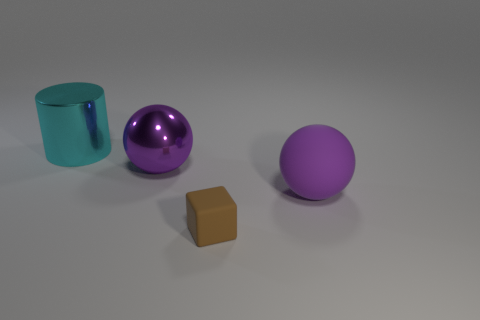Are there an equal number of tiny brown objects right of the small brown block and cylinders on the right side of the big purple rubber ball?
Provide a succinct answer. Yes. How many other things are there of the same color as the big rubber object?
Offer a terse response. 1. Does the metallic cylinder have the same color as the sphere that is to the right of the large purple shiny ball?
Provide a short and direct response. No. What number of gray objects are either matte balls or matte blocks?
Your answer should be very brief. 0. Are there the same number of brown matte objects behind the large cylinder and small brown blocks?
Provide a short and direct response. No. Is there anything else that has the same size as the cyan cylinder?
Provide a succinct answer. Yes. The shiny thing that is the same shape as the purple matte thing is what color?
Your answer should be very brief. Purple. How many small rubber things are the same shape as the cyan metal object?
Provide a succinct answer. 0. There is a large sphere that is the same color as the big rubber thing; what is it made of?
Provide a short and direct response. Metal. What number of large purple spheres are there?
Your answer should be compact. 2. 